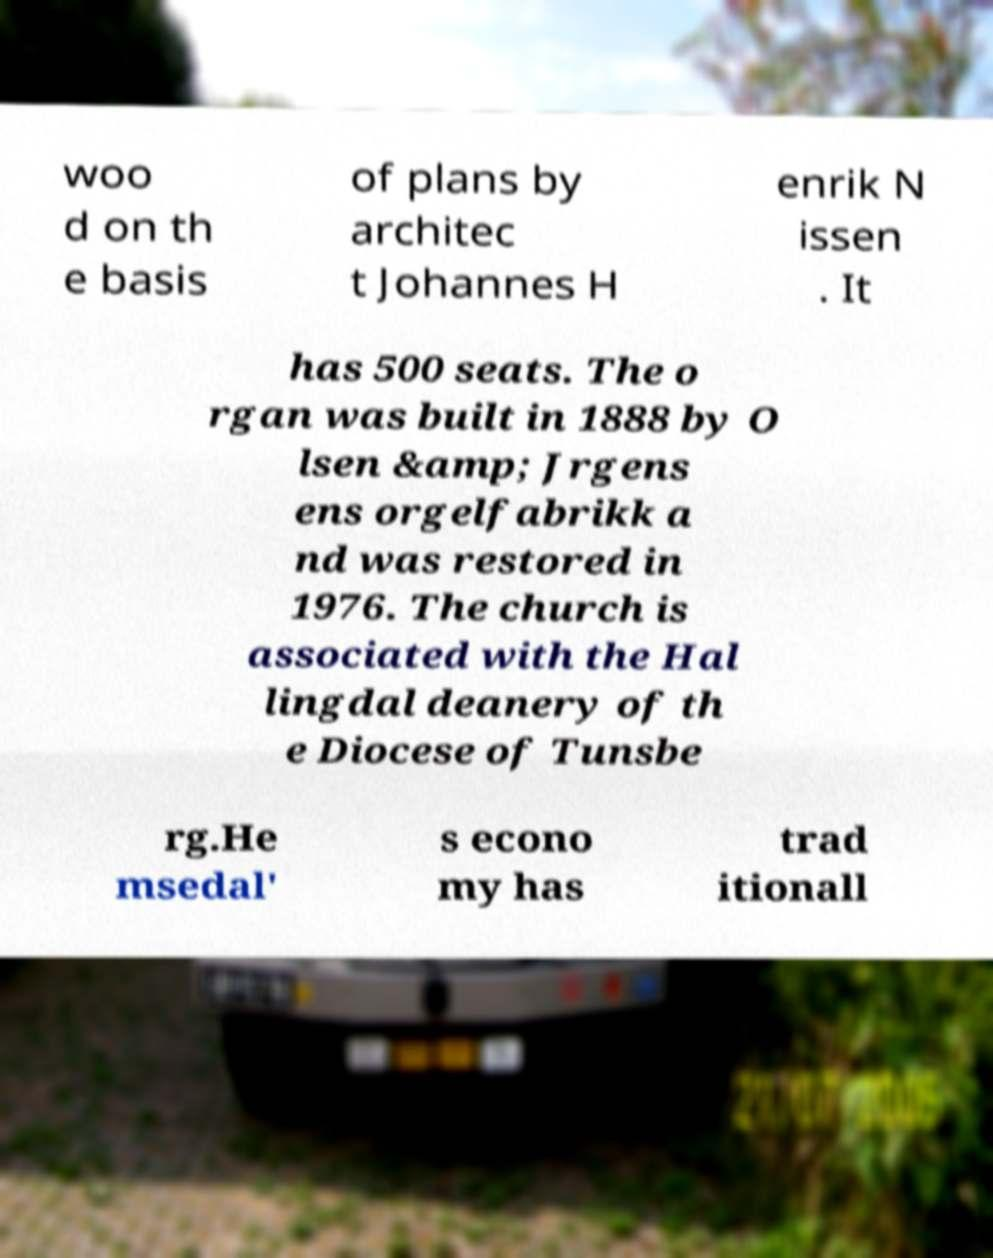What messages or text are displayed in this image? I need them in a readable, typed format. woo d on th e basis of plans by architec t Johannes H enrik N issen . It has 500 seats. The o rgan was built in 1888 by O lsen &amp; Jrgens ens orgelfabrikk a nd was restored in 1976. The church is associated with the Hal lingdal deanery of th e Diocese of Tunsbe rg.He msedal' s econo my has trad itionall 